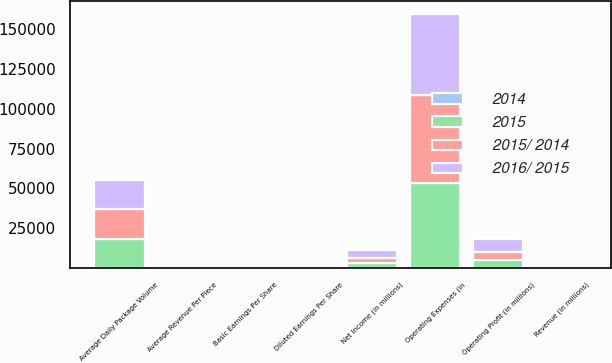<chart> <loc_0><loc_0><loc_500><loc_500><stacked_bar_chart><ecel><fcel>Revenue (in millions)<fcel>Operating Expenses (in<fcel>Operating Profit (in millions)<fcel>Average Daily Package Volume<fcel>Average Revenue Per Piece<fcel>Net Income (in millions)<fcel>Basic Earnings Per Share<fcel>Diluted Earnings Per Share<nl><fcel>2015/ 2014<fcel>27.7<fcel>55439<fcel>5467<fcel>19090<fcel>10.3<fcel>3431<fcel>3.89<fcel>3.87<nl><fcel>2016/ 2015<fcel>27.7<fcel>50695<fcel>7668<fcel>18324<fcel>10.37<fcel>4844<fcel>5.38<fcel>5.35<nl><fcel>2015<fcel>27.7<fcel>53264<fcel>4968<fcel>18016<fcel>10.58<fcel>3032<fcel>3.31<fcel>3.28<nl><fcel>2014<fcel>4.4<fcel>9.4<fcel>28.7<fcel>4.2<fcel>0.7<fcel>29.2<fcel>27.7<fcel>27.7<nl></chart> 